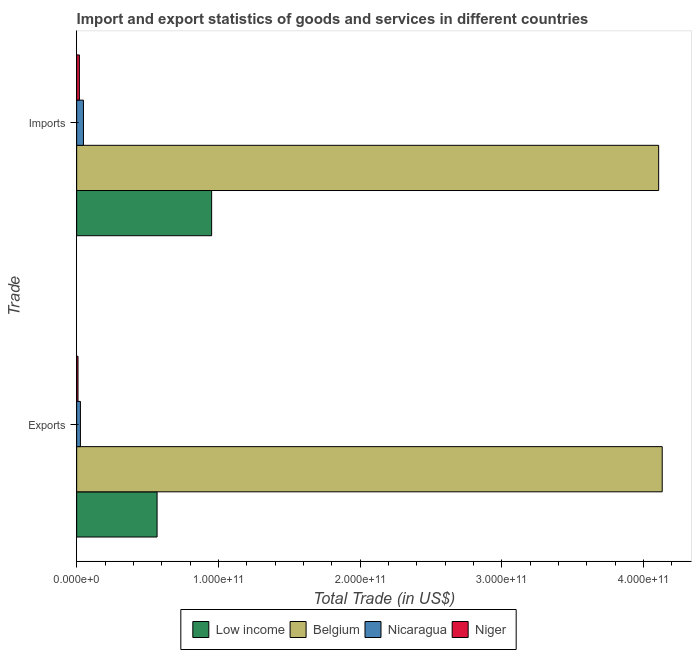How many groups of bars are there?
Provide a short and direct response. 2. Are the number of bars per tick equal to the number of legend labels?
Keep it short and to the point. Yes. What is the label of the 1st group of bars from the top?
Give a very brief answer. Imports. What is the imports of goods and services in Niger?
Offer a very short reply. 1.93e+09. Across all countries, what is the maximum export of goods and services?
Your answer should be very brief. 4.13e+11. Across all countries, what is the minimum export of goods and services?
Offer a very short reply. 9.58e+08. In which country was the export of goods and services minimum?
Ensure brevity in your answer.  Niger. What is the total imports of goods and services in the graph?
Provide a succinct answer. 5.13e+11. What is the difference between the export of goods and services in Nicaragua and that in Belgium?
Provide a short and direct response. -4.11e+11. What is the difference between the export of goods and services in Nicaragua and the imports of goods and services in Belgium?
Your response must be concise. -4.08e+11. What is the average export of goods and services per country?
Ensure brevity in your answer.  1.18e+11. What is the difference between the imports of goods and services and export of goods and services in Belgium?
Keep it short and to the point. -2.51e+09. What is the ratio of the imports of goods and services in Niger to that in Nicaragua?
Provide a short and direct response. 0.4. In how many countries, is the export of goods and services greater than the average export of goods and services taken over all countries?
Offer a very short reply. 1. What does the 1st bar from the top in Imports represents?
Your answer should be very brief. Niger. What does the 2nd bar from the bottom in Imports represents?
Provide a succinct answer. Belgium. How many bars are there?
Keep it short and to the point. 8. What is the difference between two consecutive major ticks on the X-axis?
Offer a terse response. 1.00e+11. Are the values on the major ticks of X-axis written in scientific E-notation?
Offer a very short reply. Yes. Does the graph contain any zero values?
Provide a short and direct response. No. Does the graph contain grids?
Keep it short and to the point. No. How are the legend labels stacked?
Give a very brief answer. Horizontal. What is the title of the graph?
Make the answer very short. Import and export statistics of goods and services in different countries. What is the label or title of the X-axis?
Your response must be concise. Total Trade (in US$). What is the label or title of the Y-axis?
Make the answer very short. Trade. What is the Total Trade (in US$) of Low income in Exports?
Offer a terse response. 5.68e+1. What is the Total Trade (in US$) of Belgium in Exports?
Give a very brief answer. 4.13e+11. What is the Total Trade (in US$) of Nicaragua in Exports?
Your answer should be very brief. 2.66e+09. What is the Total Trade (in US$) of Niger in Exports?
Offer a terse response. 9.58e+08. What is the Total Trade (in US$) of Low income in Imports?
Give a very brief answer. 9.53e+1. What is the Total Trade (in US$) in Belgium in Imports?
Offer a very short reply. 4.11e+11. What is the Total Trade (in US$) in Nicaragua in Imports?
Ensure brevity in your answer.  4.79e+09. What is the Total Trade (in US$) in Niger in Imports?
Ensure brevity in your answer.  1.93e+09. Across all Trade, what is the maximum Total Trade (in US$) in Low income?
Keep it short and to the point. 9.53e+1. Across all Trade, what is the maximum Total Trade (in US$) in Belgium?
Your response must be concise. 4.13e+11. Across all Trade, what is the maximum Total Trade (in US$) of Nicaragua?
Provide a short and direct response. 4.79e+09. Across all Trade, what is the maximum Total Trade (in US$) of Niger?
Your response must be concise. 1.93e+09. Across all Trade, what is the minimum Total Trade (in US$) of Low income?
Provide a succinct answer. 5.68e+1. Across all Trade, what is the minimum Total Trade (in US$) in Belgium?
Give a very brief answer. 4.11e+11. Across all Trade, what is the minimum Total Trade (in US$) of Nicaragua?
Make the answer very short. 2.66e+09. Across all Trade, what is the minimum Total Trade (in US$) of Niger?
Your answer should be very brief. 9.58e+08. What is the total Total Trade (in US$) of Low income in the graph?
Make the answer very short. 1.52e+11. What is the total Total Trade (in US$) in Belgium in the graph?
Provide a succinct answer. 8.24e+11. What is the total Total Trade (in US$) of Nicaragua in the graph?
Your answer should be very brief. 7.45e+09. What is the total Total Trade (in US$) of Niger in the graph?
Give a very brief answer. 2.89e+09. What is the difference between the Total Trade (in US$) in Low income in Exports and that in Imports?
Your answer should be compact. -3.85e+1. What is the difference between the Total Trade (in US$) in Belgium in Exports and that in Imports?
Your answer should be compact. 2.51e+09. What is the difference between the Total Trade (in US$) of Nicaragua in Exports and that in Imports?
Offer a terse response. -2.13e+09. What is the difference between the Total Trade (in US$) of Niger in Exports and that in Imports?
Offer a very short reply. -9.70e+08. What is the difference between the Total Trade (in US$) of Low income in Exports and the Total Trade (in US$) of Belgium in Imports?
Your response must be concise. -3.54e+11. What is the difference between the Total Trade (in US$) in Low income in Exports and the Total Trade (in US$) in Nicaragua in Imports?
Your answer should be compact. 5.20e+1. What is the difference between the Total Trade (in US$) of Low income in Exports and the Total Trade (in US$) of Niger in Imports?
Your answer should be compact. 5.48e+1. What is the difference between the Total Trade (in US$) of Belgium in Exports and the Total Trade (in US$) of Nicaragua in Imports?
Offer a terse response. 4.09e+11. What is the difference between the Total Trade (in US$) of Belgium in Exports and the Total Trade (in US$) of Niger in Imports?
Your answer should be compact. 4.11e+11. What is the difference between the Total Trade (in US$) of Nicaragua in Exports and the Total Trade (in US$) of Niger in Imports?
Your answer should be compact. 7.32e+08. What is the average Total Trade (in US$) in Low income per Trade?
Provide a short and direct response. 7.60e+1. What is the average Total Trade (in US$) of Belgium per Trade?
Keep it short and to the point. 4.12e+11. What is the average Total Trade (in US$) in Nicaragua per Trade?
Offer a very short reply. 3.73e+09. What is the average Total Trade (in US$) in Niger per Trade?
Keep it short and to the point. 1.44e+09. What is the difference between the Total Trade (in US$) of Low income and Total Trade (in US$) of Belgium in Exports?
Provide a succinct answer. -3.57e+11. What is the difference between the Total Trade (in US$) of Low income and Total Trade (in US$) of Nicaragua in Exports?
Provide a short and direct response. 5.41e+1. What is the difference between the Total Trade (in US$) of Low income and Total Trade (in US$) of Niger in Exports?
Offer a very short reply. 5.58e+1. What is the difference between the Total Trade (in US$) of Belgium and Total Trade (in US$) of Nicaragua in Exports?
Your response must be concise. 4.11e+11. What is the difference between the Total Trade (in US$) of Belgium and Total Trade (in US$) of Niger in Exports?
Offer a very short reply. 4.12e+11. What is the difference between the Total Trade (in US$) in Nicaragua and Total Trade (in US$) in Niger in Exports?
Provide a succinct answer. 1.70e+09. What is the difference between the Total Trade (in US$) in Low income and Total Trade (in US$) in Belgium in Imports?
Offer a terse response. -3.16e+11. What is the difference between the Total Trade (in US$) in Low income and Total Trade (in US$) in Nicaragua in Imports?
Provide a succinct answer. 9.05e+1. What is the difference between the Total Trade (in US$) in Low income and Total Trade (in US$) in Niger in Imports?
Make the answer very short. 9.34e+1. What is the difference between the Total Trade (in US$) in Belgium and Total Trade (in US$) in Nicaragua in Imports?
Give a very brief answer. 4.06e+11. What is the difference between the Total Trade (in US$) of Belgium and Total Trade (in US$) of Niger in Imports?
Keep it short and to the point. 4.09e+11. What is the difference between the Total Trade (in US$) in Nicaragua and Total Trade (in US$) in Niger in Imports?
Your response must be concise. 2.86e+09. What is the ratio of the Total Trade (in US$) of Low income in Exports to that in Imports?
Offer a very short reply. 0.6. What is the ratio of the Total Trade (in US$) in Nicaragua in Exports to that in Imports?
Give a very brief answer. 0.56. What is the ratio of the Total Trade (in US$) of Niger in Exports to that in Imports?
Make the answer very short. 0.5. What is the difference between the highest and the second highest Total Trade (in US$) in Low income?
Your answer should be compact. 3.85e+1. What is the difference between the highest and the second highest Total Trade (in US$) in Belgium?
Ensure brevity in your answer.  2.51e+09. What is the difference between the highest and the second highest Total Trade (in US$) of Nicaragua?
Give a very brief answer. 2.13e+09. What is the difference between the highest and the second highest Total Trade (in US$) of Niger?
Provide a short and direct response. 9.70e+08. What is the difference between the highest and the lowest Total Trade (in US$) in Low income?
Offer a very short reply. 3.85e+1. What is the difference between the highest and the lowest Total Trade (in US$) in Belgium?
Ensure brevity in your answer.  2.51e+09. What is the difference between the highest and the lowest Total Trade (in US$) of Nicaragua?
Make the answer very short. 2.13e+09. What is the difference between the highest and the lowest Total Trade (in US$) in Niger?
Your answer should be very brief. 9.70e+08. 